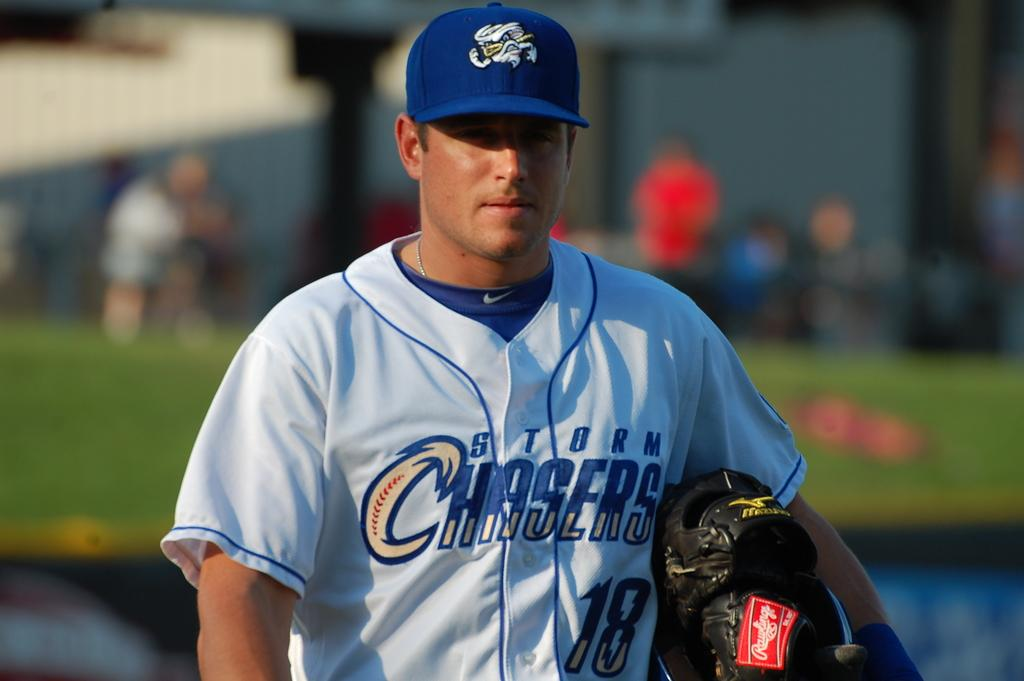<image>
Summarize the visual content of the image. A baseball player wearing a jersey for the team Storm Chasers. 